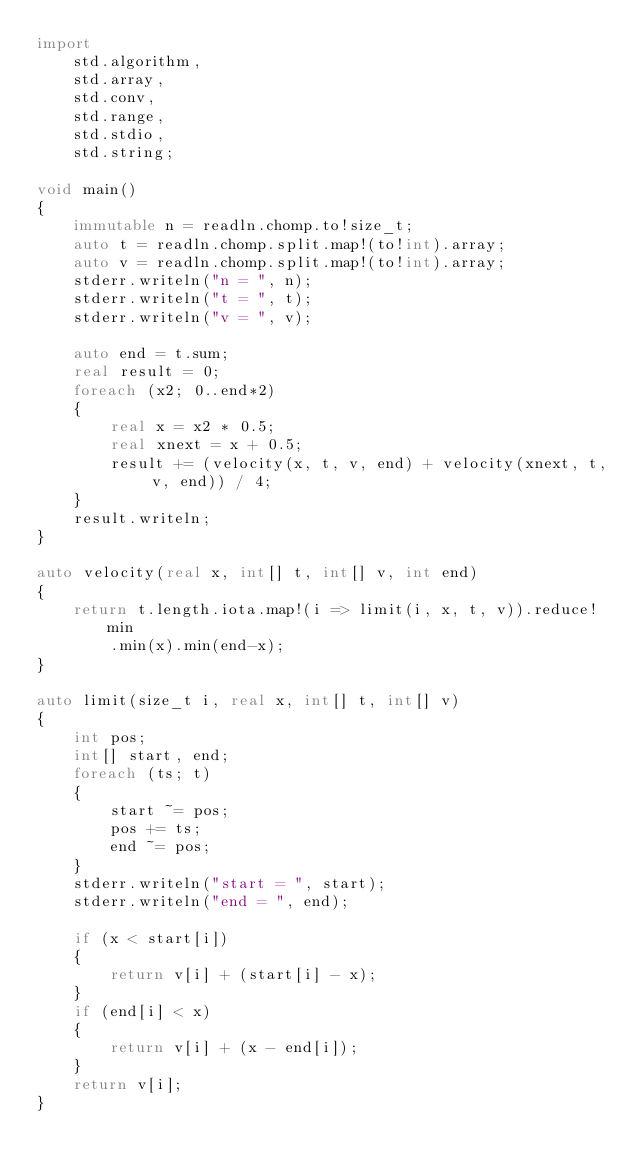<code> <loc_0><loc_0><loc_500><loc_500><_D_>import
    std.algorithm,
    std.array,
    std.conv,
    std.range,
    std.stdio,
    std.string;

void main()
{
    immutable n = readln.chomp.to!size_t;
    auto t = readln.chomp.split.map!(to!int).array;
    auto v = readln.chomp.split.map!(to!int).array;
    stderr.writeln("n = ", n);
    stderr.writeln("t = ", t);
    stderr.writeln("v = ", v);

    auto end = t.sum;
    real result = 0;
    foreach (x2; 0..end*2)
    {
        real x = x2 * 0.5;
        real xnext = x + 0.5;
        result += (velocity(x, t, v, end) + velocity(xnext, t, v, end)) / 4;
    }
    result.writeln;
}

auto velocity(real x, int[] t, int[] v, int end)
{
    return t.length.iota.map!(i => limit(i, x, t, v)).reduce!min
        .min(x).min(end-x);
}

auto limit(size_t i, real x, int[] t, int[] v)
{
    int pos;
    int[] start, end;
    foreach (ts; t)
    {
        start ~= pos;
        pos += ts;
        end ~= pos;
    }
    stderr.writeln("start = ", start);
    stderr.writeln("end = ", end);

    if (x < start[i])
    {
        return v[i] + (start[i] - x);
    }
    if (end[i] < x)
    {
        return v[i] + (x - end[i]);
    }
    return v[i];
}
</code> 